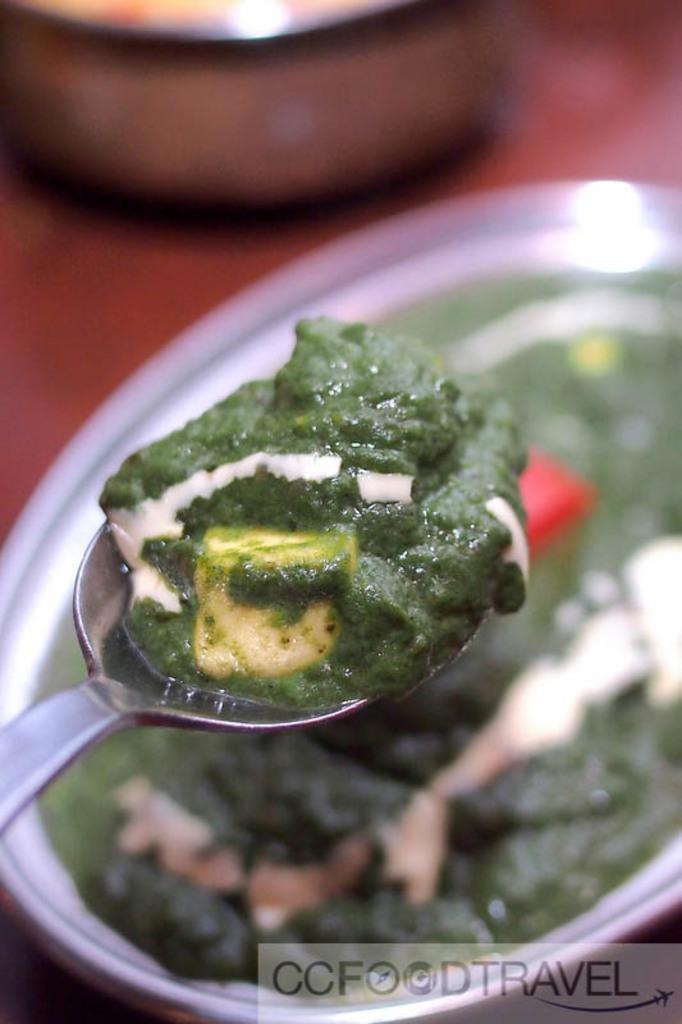What is on the serving plate in the image? The serving plate contains food. What utensil is present in the image? There is a spoon in the image. Can you describe the type of food on the serving plate? Unfortunately, the specific type of food cannot be determined from the provided facts. How many cows are grazing on the grass in the image? There are no cows or grass present in the image. 